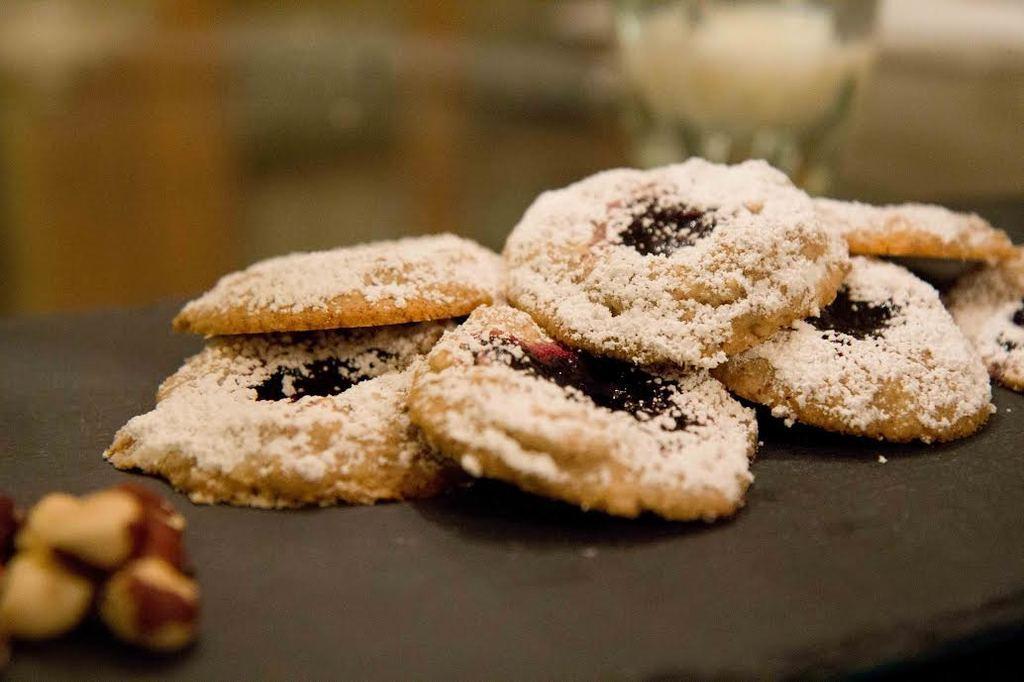How would you summarize this image in a sentence or two? In this image we can see some food on an object. There is a blur background in the image. 